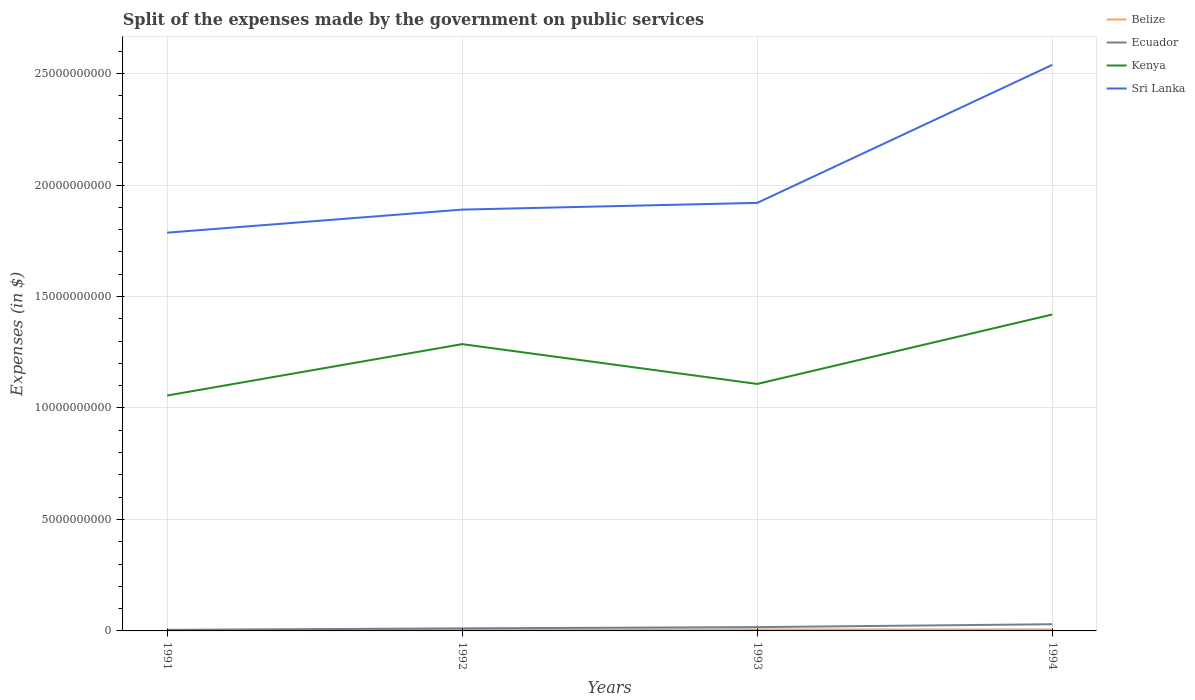How many different coloured lines are there?
Keep it short and to the point. 4. Does the line corresponding to Belize intersect with the line corresponding to Kenya?
Offer a terse response. No. Across all years, what is the maximum expenses made by the government on public services in Ecuador?
Offer a very short reply. 4.80e+07. What is the total expenses made by the government on public services in Belize in the graph?
Provide a succinct answer. -9.09e+06. What is the difference between the highest and the second highest expenses made by the government on public services in Kenya?
Your answer should be compact. 3.64e+09. Is the expenses made by the government on public services in Sri Lanka strictly greater than the expenses made by the government on public services in Kenya over the years?
Give a very brief answer. No. Are the values on the major ticks of Y-axis written in scientific E-notation?
Provide a short and direct response. No. How many legend labels are there?
Provide a short and direct response. 4. What is the title of the graph?
Make the answer very short. Split of the expenses made by the government on public services. What is the label or title of the Y-axis?
Ensure brevity in your answer.  Expenses (in $). What is the Expenses (in $) in Belize in 1991?
Your response must be concise. 2.97e+07. What is the Expenses (in $) of Ecuador in 1991?
Keep it short and to the point. 4.80e+07. What is the Expenses (in $) in Kenya in 1991?
Offer a terse response. 1.06e+1. What is the Expenses (in $) in Sri Lanka in 1991?
Make the answer very short. 1.79e+1. What is the Expenses (in $) of Belize in 1992?
Your response must be concise. 5.55e+07. What is the Expenses (in $) in Ecuador in 1992?
Your answer should be very brief. 1.15e+08. What is the Expenses (in $) of Kenya in 1992?
Your answer should be very brief. 1.29e+1. What is the Expenses (in $) of Sri Lanka in 1992?
Make the answer very short. 1.89e+1. What is the Expenses (in $) of Belize in 1993?
Offer a very short reply. 6.46e+07. What is the Expenses (in $) in Ecuador in 1993?
Your answer should be very brief. 1.70e+08. What is the Expenses (in $) in Kenya in 1993?
Give a very brief answer. 1.11e+1. What is the Expenses (in $) of Sri Lanka in 1993?
Your answer should be compact. 1.92e+1. What is the Expenses (in $) of Belize in 1994?
Provide a succinct answer. 6.72e+07. What is the Expenses (in $) in Ecuador in 1994?
Provide a succinct answer. 3.00e+08. What is the Expenses (in $) of Kenya in 1994?
Offer a very short reply. 1.42e+1. What is the Expenses (in $) in Sri Lanka in 1994?
Your answer should be compact. 2.54e+1. Across all years, what is the maximum Expenses (in $) of Belize?
Provide a succinct answer. 6.72e+07. Across all years, what is the maximum Expenses (in $) in Ecuador?
Keep it short and to the point. 3.00e+08. Across all years, what is the maximum Expenses (in $) in Kenya?
Provide a succinct answer. 1.42e+1. Across all years, what is the maximum Expenses (in $) in Sri Lanka?
Make the answer very short. 2.54e+1. Across all years, what is the minimum Expenses (in $) in Belize?
Offer a very short reply. 2.97e+07. Across all years, what is the minimum Expenses (in $) in Ecuador?
Provide a succinct answer. 4.80e+07. Across all years, what is the minimum Expenses (in $) of Kenya?
Your answer should be compact. 1.06e+1. Across all years, what is the minimum Expenses (in $) in Sri Lanka?
Your response must be concise. 1.79e+1. What is the total Expenses (in $) of Belize in the graph?
Your answer should be compact. 2.17e+08. What is the total Expenses (in $) of Ecuador in the graph?
Keep it short and to the point. 6.33e+08. What is the total Expenses (in $) of Kenya in the graph?
Provide a short and direct response. 4.87e+1. What is the total Expenses (in $) of Sri Lanka in the graph?
Ensure brevity in your answer.  8.14e+1. What is the difference between the Expenses (in $) in Belize in 1991 and that in 1992?
Provide a short and direct response. -2.58e+07. What is the difference between the Expenses (in $) of Ecuador in 1991 and that in 1992?
Offer a very short reply. -6.70e+07. What is the difference between the Expenses (in $) of Kenya in 1991 and that in 1992?
Your response must be concise. -2.31e+09. What is the difference between the Expenses (in $) in Sri Lanka in 1991 and that in 1992?
Your answer should be very brief. -1.04e+09. What is the difference between the Expenses (in $) of Belize in 1991 and that in 1993?
Provide a succinct answer. -3.49e+07. What is the difference between the Expenses (in $) of Ecuador in 1991 and that in 1993?
Keep it short and to the point. -1.22e+08. What is the difference between the Expenses (in $) of Kenya in 1991 and that in 1993?
Provide a succinct answer. -5.20e+08. What is the difference between the Expenses (in $) of Sri Lanka in 1991 and that in 1993?
Offer a very short reply. -1.34e+09. What is the difference between the Expenses (in $) in Belize in 1991 and that in 1994?
Offer a very short reply. -3.75e+07. What is the difference between the Expenses (in $) in Ecuador in 1991 and that in 1994?
Make the answer very short. -2.52e+08. What is the difference between the Expenses (in $) in Kenya in 1991 and that in 1994?
Provide a short and direct response. -3.64e+09. What is the difference between the Expenses (in $) in Sri Lanka in 1991 and that in 1994?
Your response must be concise. -7.53e+09. What is the difference between the Expenses (in $) of Belize in 1992 and that in 1993?
Your response must be concise. -9.09e+06. What is the difference between the Expenses (in $) in Ecuador in 1992 and that in 1993?
Keep it short and to the point. -5.50e+07. What is the difference between the Expenses (in $) in Kenya in 1992 and that in 1993?
Your answer should be very brief. 1.79e+09. What is the difference between the Expenses (in $) in Sri Lanka in 1992 and that in 1993?
Your answer should be very brief. -3.02e+08. What is the difference between the Expenses (in $) in Belize in 1992 and that in 1994?
Your answer should be very brief. -1.17e+07. What is the difference between the Expenses (in $) in Ecuador in 1992 and that in 1994?
Offer a terse response. -1.85e+08. What is the difference between the Expenses (in $) in Kenya in 1992 and that in 1994?
Your answer should be very brief. -1.33e+09. What is the difference between the Expenses (in $) of Sri Lanka in 1992 and that in 1994?
Give a very brief answer. -6.49e+09. What is the difference between the Expenses (in $) in Belize in 1993 and that in 1994?
Ensure brevity in your answer.  -2.61e+06. What is the difference between the Expenses (in $) in Ecuador in 1993 and that in 1994?
Give a very brief answer. -1.30e+08. What is the difference between the Expenses (in $) of Kenya in 1993 and that in 1994?
Your answer should be very brief. -3.12e+09. What is the difference between the Expenses (in $) in Sri Lanka in 1993 and that in 1994?
Keep it short and to the point. -6.19e+09. What is the difference between the Expenses (in $) of Belize in 1991 and the Expenses (in $) of Ecuador in 1992?
Your answer should be compact. -8.53e+07. What is the difference between the Expenses (in $) in Belize in 1991 and the Expenses (in $) in Kenya in 1992?
Offer a terse response. -1.28e+1. What is the difference between the Expenses (in $) of Belize in 1991 and the Expenses (in $) of Sri Lanka in 1992?
Offer a terse response. -1.89e+1. What is the difference between the Expenses (in $) in Ecuador in 1991 and the Expenses (in $) in Kenya in 1992?
Keep it short and to the point. -1.28e+1. What is the difference between the Expenses (in $) of Ecuador in 1991 and the Expenses (in $) of Sri Lanka in 1992?
Provide a short and direct response. -1.88e+1. What is the difference between the Expenses (in $) of Kenya in 1991 and the Expenses (in $) of Sri Lanka in 1992?
Your response must be concise. -8.34e+09. What is the difference between the Expenses (in $) of Belize in 1991 and the Expenses (in $) of Ecuador in 1993?
Keep it short and to the point. -1.40e+08. What is the difference between the Expenses (in $) of Belize in 1991 and the Expenses (in $) of Kenya in 1993?
Provide a short and direct response. -1.10e+1. What is the difference between the Expenses (in $) of Belize in 1991 and the Expenses (in $) of Sri Lanka in 1993?
Your answer should be compact. -1.92e+1. What is the difference between the Expenses (in $) in Ecuador in 1991 and the Expenses (in $) in Kenya in 1993?
Provide a short and direct response. -1.10e+1. What is the difference between the Expenses (in $) of Ecuador in 1991 and the Expenses (in $) of Sri Lanka in 1993?
Your response must be concise. -1.92e+1. What is the difference between the Expenses (in $) in Kenya in 1991 and the Expenses (in $) in Sri Lanka in 1993?
Provide a short and direct response. -8.64e+09. What is the difference between the Expenses (in $) in Belize in 1991 and the Expenses (in $) in Ecuador in 1994?
Your answer should be compact. -2.70e+08. What is the difference between the Expenses (in $) in Belize in 1991 and the Expenses (in $) in Kenya in 1994?
Your answer should be very brief. -1.42e+1. What is the difference between the Expenses (in $) in Belize in 1991 and the Expenses (in $) in Sri Lanka in 1994?
Offer a very short reply. -2.54e+1. What is the difference between the Expenses (in $) in Ecuador in 1991 and the Expenses (in $) in Kenya in 1994?
Offer a terse response. -1.41e+1. What is the difference between the Expenses (in $) in Ecuador in 1991 and the Expenses (in $) in Sri Lanka in 1994?
Make the answer very short. -2.53e+1. What is the difference between the Expenses (in $) of Kenya in 1991 and the Expenses (in $) of Sri Lanka in 1994?
Give a very brief answer. -1.48e+1. What is the difference between the Expenses (in $) in Belize in 1992 and the Expenses (in $) in Ecuador in 1993?
Offer a very short reply. -1.15e+08. What is the difference between the Expenses (in $) of Belize in 1992 and the Expenses (in $) of Kenya in 1993?
Your response must be concise. -1.10e+1. What is the difference between the Expenses (in $) in Belize in 1992 and the Expenses (in $) in Sri Lanka in 1993?
Keep it short and to the point. -1.91e+1. What is the difference between the Expenses (in $) in Ecuador in 1992 and the Expenses (in $) in Kenya in 1993?
Keep it short and to the point. -1.10e+1. What is the difference between the Expenses (in $) of Ecuador in 1992 and the Expenses (in $) of Sri Lanka in 1993?
Keep it short and to the point. -1.91e+1. What is the difference between the Expenses (in $) of Kenya in 1992 and the Expenses (in $) of Sri Lanka in 1993?
Provide a short and direct response. -6.34e+09. What is the difference between the Expenses (in $) of Belize in 1992 and the Expenses (in $) of Ecuador in 1994?
Offer a terse response. -2.45e+08. What is the difference between the Expenses (in $) in Belize in 1992 and the Expenses (in $) in Kenya in 1994?
Your response must be concise. -1.41e+1. What is the difference between the Expenses (in $) of Belize in 1992 and the Expenses (in $) of Sri Lanka in 1994?
Offer a terse response. -2.53e+1. What is the difference between the Expenses (in $) in Ecuador in 1992 and the Expenses (in $) in Kenya in 1994?
Provide a short and direct response. -1.41e+1. What is the difference between the Expenses (in $) of Ecuador in 1992 and the Expenses (in $) of Sri Lanka in 1994?
Make the answer very short. -2.53e+1. What is the difference between the Expenses (in $) in Kenya in 1992 and the Expenses (in $) in Sri Lanka in 1994?
Keep it short and to the point. -1.25e+1. What is the difference between the Expenses (in $) of Belize in 1993 and the Expenses (in $) of Ecuador in 1994?
Offer a very short reply. -2.35e+08. What is the difference between the Expenses (in $) of Belize in 1993 and the Expenses (in $) of Kenya in 1994?
Provide a succinct answer. -1.41e+1. What is the difference between the Expenses (in $) of Belize in 1993 and the Expenses (in $) of Sri Lanka in 1994?
Provide a short and direct response. -2.53e+1. What is the difference between the Expenses (in $) in Ecuador in 1993 and the Expenses (in $) in Kenya in 1994?
Keep it short and to the point. -1.40e+1. What is the difference between the Expenses (in $) of Ecuador in 1993 and the Expenses (in $) of Sri Lanka in 1994?
Your answer should be very brief. -2.52e+1. What is the difference between the Expenses (in $) in Kenya in 1993 and the Expenses (in $) in Sri Lanka in 1994?
Ensure brevity in your answer.  -1.43e+1. What is the average Expenses (in $) of Belize per year?
Make the answer very short. 5.42e+07. What is the average Expenses (in $) of Ecuador per year?
Offer a terse response. 1.58e+08. What is the average Expenses (in $) in Kenya per year?
Offer a terse response. 1.22e+1. What is the average Expenses (in $) in Sri Lanka per year?
Your response must be concise. 2.03e+1. In the year 1991, what is the difference between the Expenses (in $) in Belize and Expenses (in $) in Ecuador?
Offer a very short reply. -1.83e+07. In the year 1991, what is the difference between the Expenses (in $) of Belize and Expenses (in $) of Kenya?
Your answer should be compact. -1.05e+1. In the year 1991, what is the difference between the Expenses (in $) of Belize and Expenses (in $) of Sri Lanka?
Your response must be concise. -1.78e+1. In the year 1991, what is the difference between the Expenses (in $) of Ecuador and Expenses (in $) of Kenya?
Ensure brevity in your answer.  -1.05e+1. In the year 1991, what is the difference between the Expenses (in $) of Ecuador and Expenses (in $) of Sri Lanka?
Provide a short and direct response. -1.78e+1. In the year 1991, what is the difference between the Expenses (in $) in Kenya and Expenses (in $) in Sri Lanka?
Offer a very short reply. -7.30e+09. In the year 1992, what is the difference between the Expenses (in $) in Belize and Expenses (in $) in Ecuador?
Your answer should be very brief. -5.95e+07. In the year 1992, what is the difference between the Expenses (in $) in Belize and Expenses (in $) in Kenya?
Keep it short and to the point. -1.28e+1. In the year 1992, what is the difference between the Expenses (in $) in Belize and Expenses (in $) in Sri Lanka?
Offer a very short reply. -1.88e+1. In the year 1992, what is the difference between the Expenses (in $) of Ecuador and Expenses (in $) of Kenya?
Your response must be concise. -1.27e+1. In the year 1992, what is the difference between the Expenses (in $) of Ecuador and Expenses (in $) of Sri Lanka?
Make the answer very short. -1.88e+1. In the year 1992, what is the difference between the Expenses (in $) in Kenya and Expenses (in $) in Sri Lanka?
Give a very brief answer. -6.03e+09. In the year 1993, what is the difference between the Expenses (in $) of Belize and Expenses (in $) of Ecuador?
Your answer should be very brief. -1.05e+08. In the year 1993, what is the difference between the Expenses (in $) in Belize and Expenses (in $) in Kenya?
Your response must be concise. -1.10e+1. In the year 1993, what is the difference between the Expenses (in $) in Belize and Expenses (in $) in Sri Lanka?
Give a very brief answer. -1.91e+1. In the year 1993, what is the difference between the Expenses (in $) of Ecuador and Expenses (in $) of Kenya?
Provide a short and direct response. -1.09e+1. In the year 1993, what is the difference between the Expenses (in $) in Ecuador and Expenses (in $) in Sri Lanka?
Your answer should be compact. -1.90e+1. In the year 1993, what is the difference between the Expenses (in $) of Kenya and Expenses (in $) of Sri Lanka?
Provide a short and direct response. -8.12e+09. In the year 1994, what is the difference between the Expenses (in $) of Belize and Expenses (in $) of Ecuador?
Your answer should be compact. -2.33e+08. In the year 1994, what is the difference between the Expenses (in $) in Belize and Expenses (in $) in Kenya?
Keep it short and to the point. -1.41e+1. In the year 1994, what is the difference between the Expenses (in $) in Belize and Expenses (in $) in Sri Lanka?
Your answer should be compact. -2.53e+1. In the year 1994, what is the difference between the Expenses (in $) of Ecuador and Expenses (in $) of Kenya?
Your response must be concise. -1.39e+1. In the year 1994, what is the difference between the Expenses (in $) of Ecuador and Expenses (in $) of Sri Lanka?
Provide a succinct answer. -2.51e+1. In the year 1994, what is the difference between the Expenses (in $) in Kenya and Expenses (in $) in Sri Lanka?
Provide a succinct answer. -1.12e+1. What is the ratio of the Expenses (in $) in Belize in 1991 to that in 1992?
Ensure brevity in your answer.  0.54. What is the ratio of the Expenses (in $) in Ecuador in 1991 to that in 1992?
Keep it short and to the point. 0.42. What is the ratio of the Expenses (in $) of Kenya in 1991 to that in 1992?
Ensure brevity in your answer.  0.82. What is the ratio of the Expenses (in $) of Sri Lanka in 1991 to that in 1992?
Offer a terse response. 0.95. What is the ratio of the Expenses (in $) of Belize in 1991 to that in 1993?
Your answer should be compact. 0.46. What is the ratio of the Expenses (in $) in Ecuador in 1991 to that in 1993?
Make the answer very short. 0.28. What is the ratio of the Expenses (in $) in Kenya in 1991 to that in 1993?
Make the answer very short. 0.95. What is the ratio of the Expenses (in $) of Sri Lanka in 1991 to that in 1993?
Provide a short and direct response. 0.93. What is the ratio of the Expenses (in $) in Belize in 1991 to that in 1994?
Your answer should be very brief. 0.44. What is the ratio of the Expenses (in $) in Ecuador in 1991 to that in 1994?
Your answer should be very brief. 0.16. What is the ratio of the Expenses (in $) in Kenya in 1991 to that in 1994?
Give a very brief answer. 0.74. What is the ratio of the Expenses (in $) in Sri Lanka in 1991 to that in 1994?
Keep it short and to the point. 0.7. What is the ratio of the Expenses (in $) in Belize in 1992 to that in 1993?
Give a very brief answer. 0.86. What is the ratio of the Expenses (in $) in Ecuador in 1992 to that in 1993?
Offer a very short reply. 0.68. What is the ratio of the Expenses (in $) of Kenya in 1992 to that in 1993?
Provide a short and direct response. 1.16. What is the ratio of the Expenses (in $) of Sri Lanka in 1992 to that in 1993?
Give a very brief answer. 0.98. What is the ratio of the Expenses (in $) of Belize in 1992 to that in 1994?
Provide a short and direct response. 0.83. What is the ratio of the Expenses (in $) in Ecuador in 1992 to that in 1994?
Make the answer very short. 0.38. What is the ratio of the Expenses (in $) in Kenya in 1992 to that in 1994?
Keep it short and to the point. 0.91. What is the ratio of the Expenses (in $) in Sri Lanka in 1992 to that in 1994?
Your answer should be very brief. 0.74. What is the ratio of the Expenses (in $) in Belize in 1993 to that in 1994?
Give a very brief answer. 0.96. What is the ratio of the Expenses (in $) of Ecuador in 1993 to that in 1994?
Provide a succinct answer. 0.57. What is the ratio of the Expenses (in $) in Kenya in 1993 to that in 1994?
Your response must be concise. 0.78. What is the ratio of the Expenses (in $) in Sri Lanka in 1993 to that in 1994?
Your response must be concise. 0.76. What is the difference between the highest and the second highest Expenses (in $) of Belize?
Your answer should be very brief. 2.61e+06. What is the difference between the highest and the second highest Expenses (in $) of Ecuador?
Your answer should be very brief. 1.30e+08. What is the difference between the highest and the second highest Expenses (in $) of Kenya?
Give a very brief answer. 1.33e+09. What is the difference between the highest and the second highest Expenses (in $) of Sri Lanka?
Keep it short and to the point. 6.19e+09. What is the difference between the highest and the lowest Expenses (in $) of Belize?
Your response must be concise. 3.75e+07. What is the difference between the highest and the lowest Expenses (in $) of Ecuador?
Offer a very short reply. 2.52e+08. What is the difference between the highest and the lowest Expenses (in $) in Kenya?
Give a very brief answer. 3.64e+09. What is the difference between the highest and the lowest Expenses (in $) of Sri Lanka?
Offer a very short reply. 7.53e+09. 